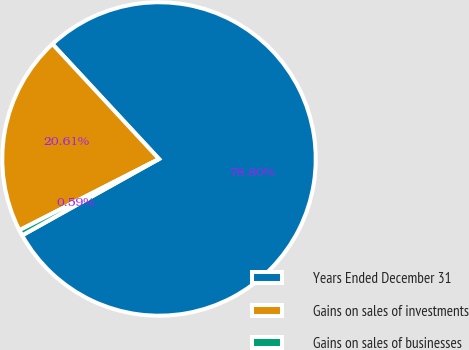Convert chart to OTSL. <chart><loc_0><loc_0><loc_500><loc_500><pie_chart><fcel>Years Ended December 31<fcel>Gains on sales of investments<fcel>Gains on sales of businesses<nl><fcel>78.8%<fcel>20.61%<fcel>0.59%<nl></chart> 